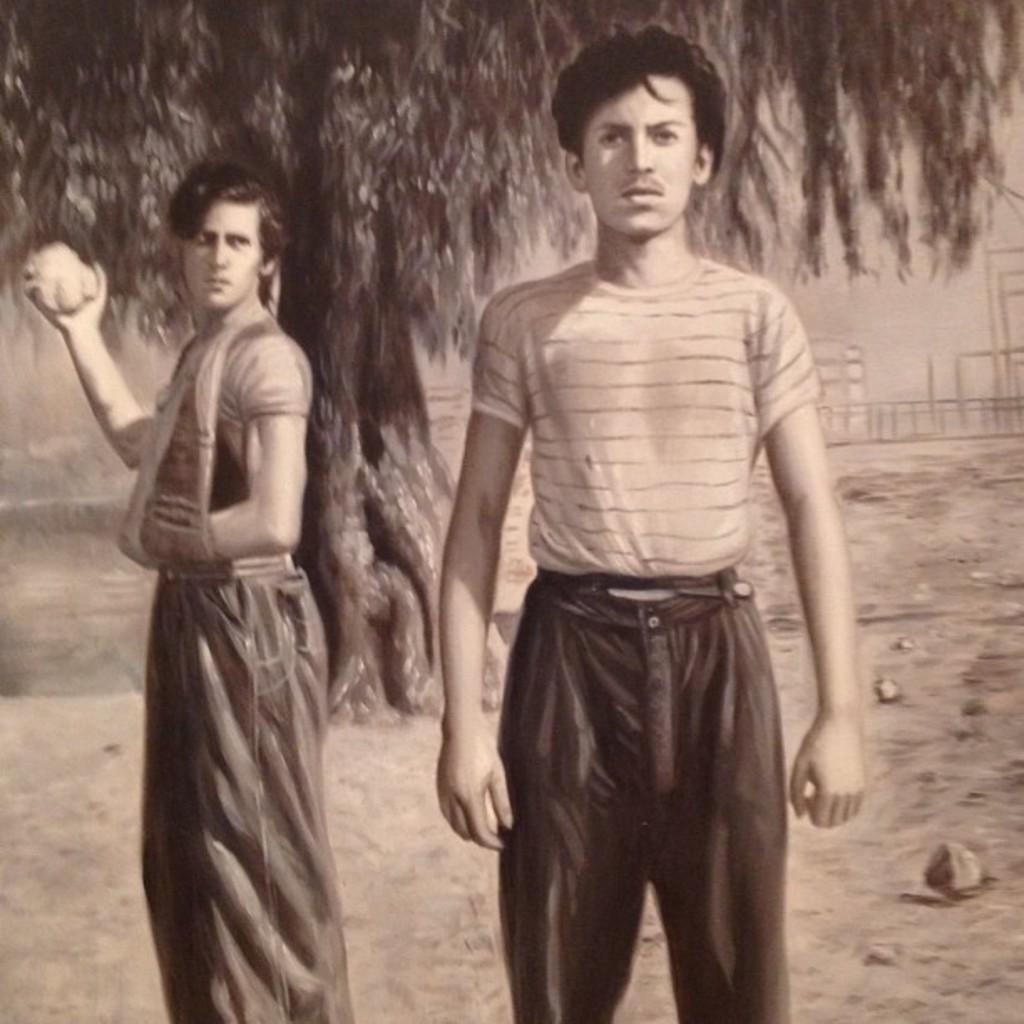Please provide a concise description of this image. In this image there is a man standing in the middle. Behind him there is another man who is holding the stone. In the background there is a tree. At the bottom there is ground on which there are stones. 